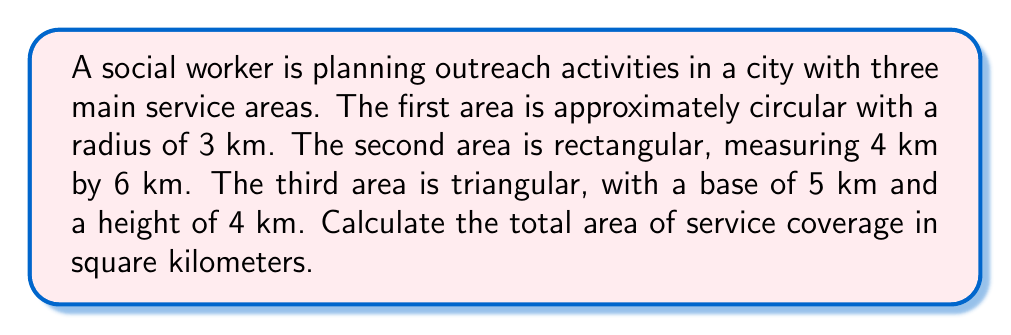Show me your answer to this math problem. To solve this problem, we need to calculate the area of each shape and then sum them up:

1. Circular area:
   The formula for the area of a circle is $A = \pi r^2$
   $$A_1 = \pi (3\text{ km})^2 = 9\pi \text{ km}^2 \approx 28.27 \text{ km}^2$$

2. Rectangular area:
   The formula for the area of a rectangle is $A = l \times w$
   $$A_2 = 4 \text{ km} \times 6 \text{ km} = 24 \text{ km}^2$$

3. Triangular area:
   The formula for the area of a triangle is $A = \frac{1}{2} \times b \times h$
   $$A_3 = \frac{1}{2} \times 5 \text{ km} \times 4 \text{ km} = 10 \text{ km}^2$$

4. Total area:
   Sum up all three areas
   $$A_{\text{total}} = A_1 + A_2 + A_3 = 28.27 + 24 + 10 = 62.27 \text{ km}^2$$

[asy]
import geometry;

size(200);

draw(circle((0,0),3), blue);
draw(box((-5,-5),(1,1)), red);
draw((5,-5)--(10,-5)--(10,-1)--cycle, green);

label("3 km", (1.5,0), E);
label("4 km", (-5,-2), W);
label("6 km", (-2,-5), S);
label("5 km", (7.5,-5), S);
label("4 km", (10,-3), E);

[/asy]
Answer: $62.27 \text{ km}^2$ 